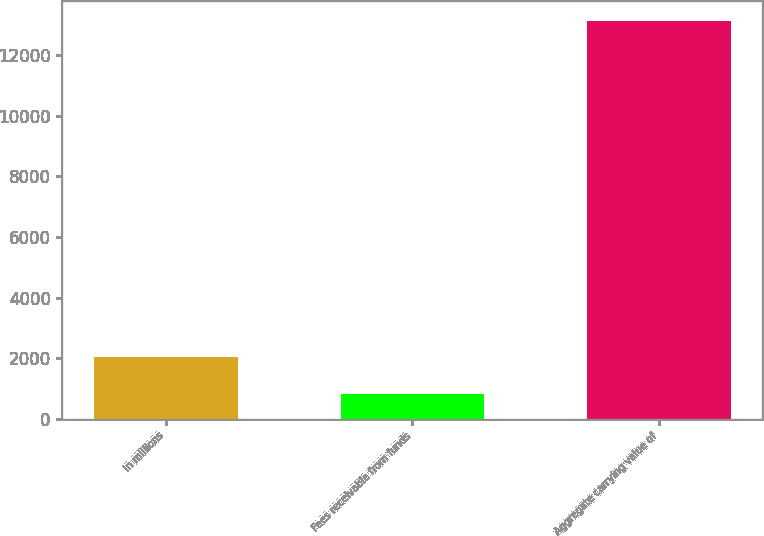Convert chart to OTSL. <chart><loc_0><loc_0><loc_500><loc_500><bar_chart><fcel>in millions<fcel>Fees receivable from funds<fcel>Aggregate carrying value of<nl><fcel>2047.7<fcel>817<fcel>13124<nl></chart> 